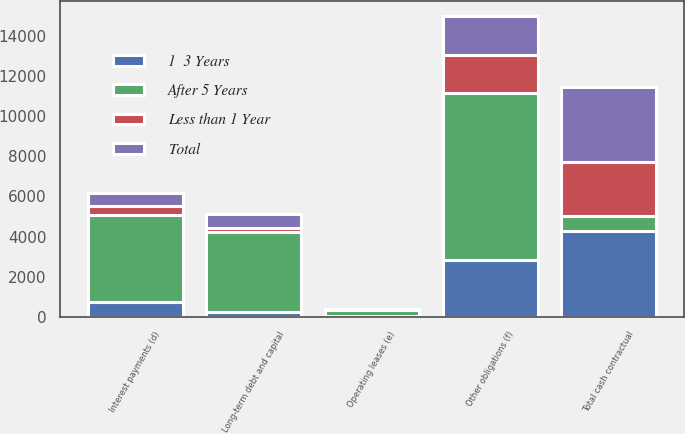Convert chart. <chart><loc_0><loc_0><loc_500><loc_500><stacked_bar_chart><ecel><fcel>Long-term debt and capital<fcel>Interest payments (d)<fcel>Operating leases (e)<fcel>Other obligations (f)<fcel>Total cash contractual<nl><fcel>After 5 Years<fcel>4013<fcel>4340<fcel>272<fcel>8338<fcel>742<nl><fcel>Less than 1 Year<fcel>205<fcel>428<fcel>31<fcel>1891<fcel>2705<nl><fcel>1  3 Years<fcel>229<fcel>742<fcel>53<fcel>2808<fcel>4257<nl><fcel>Total<fcel>697<fcel>664<fcel>51<fcel>1948<fcel>3739<nl></chart> 